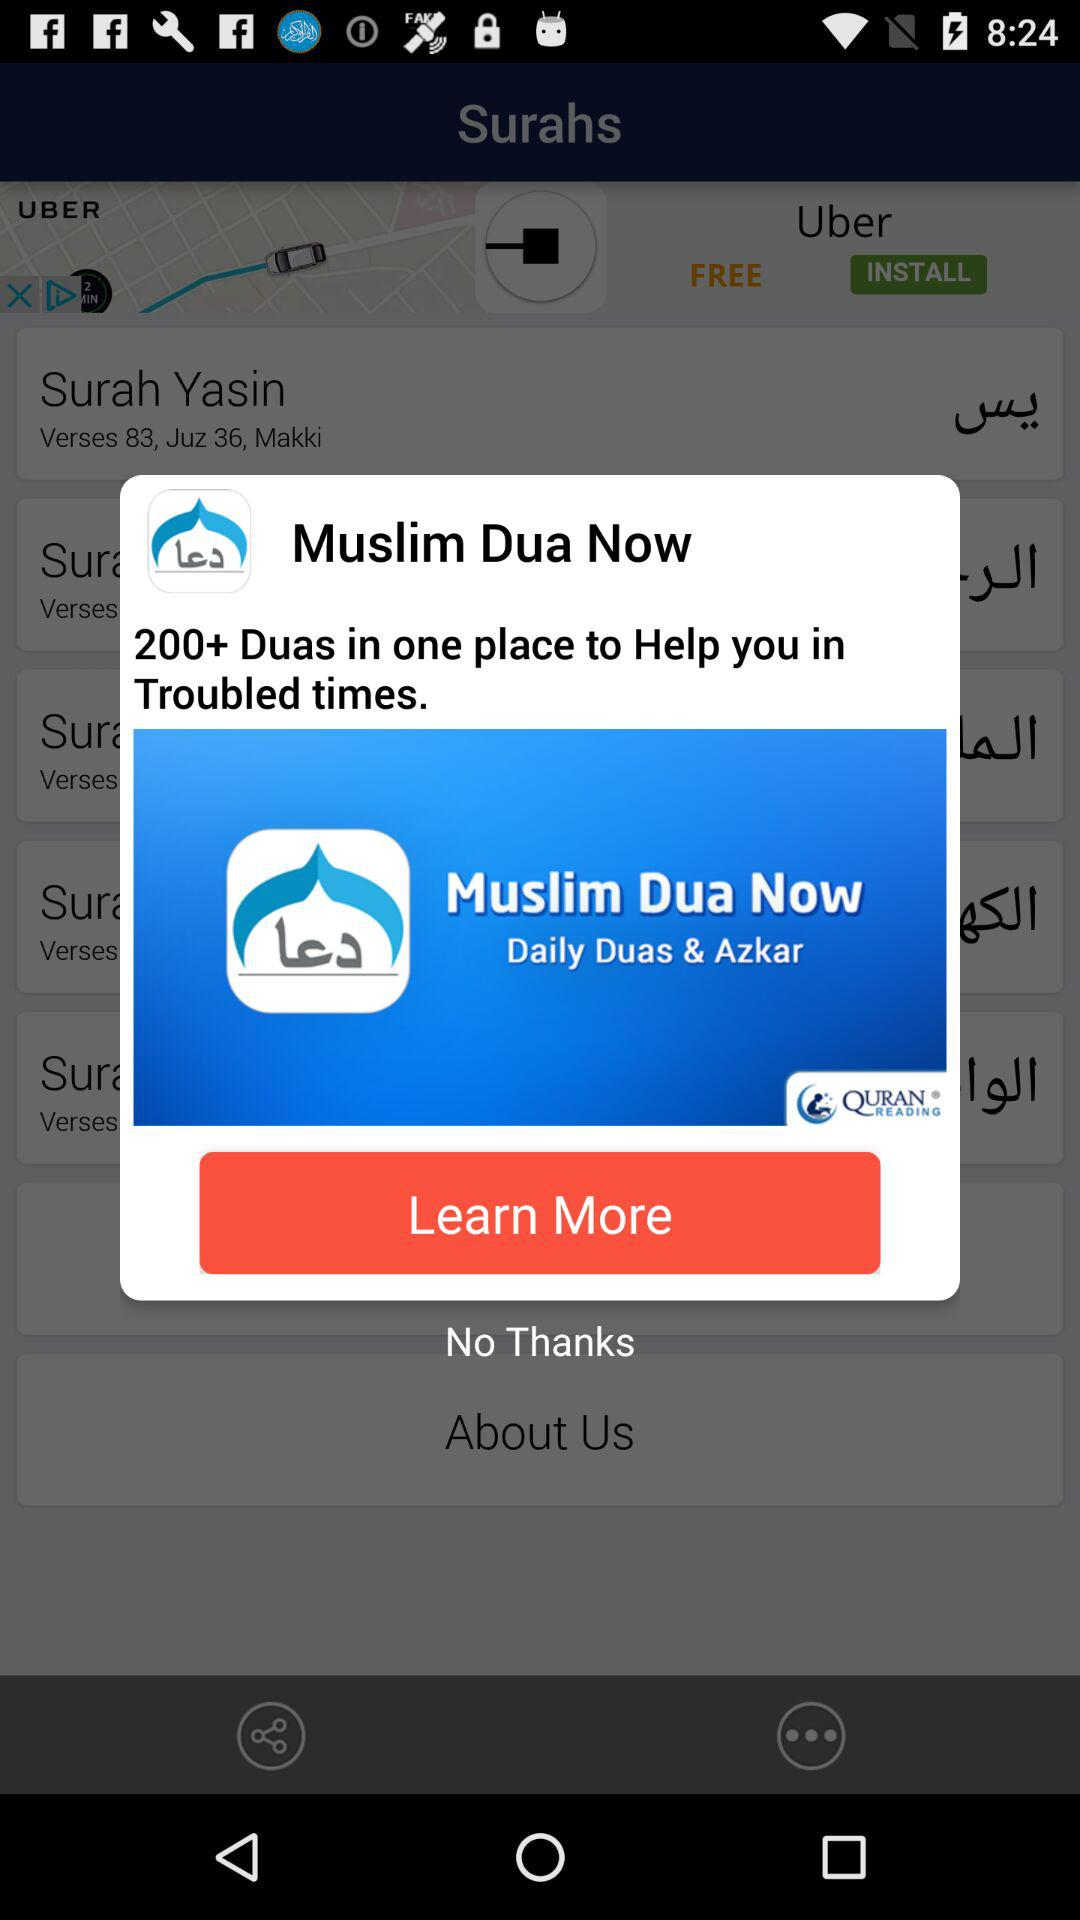How many verses are in Surah Yasin? There are 83 verses in Surah Yasin. 